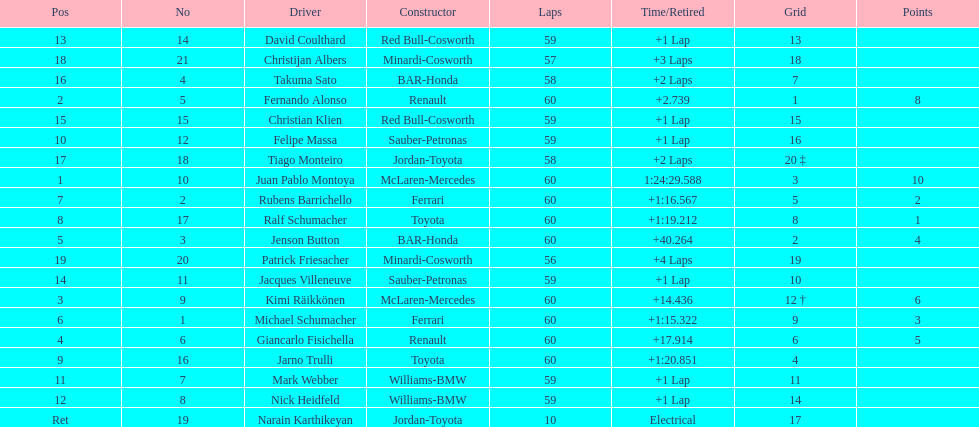Which driver has his grid at 2? Jenson Button. 